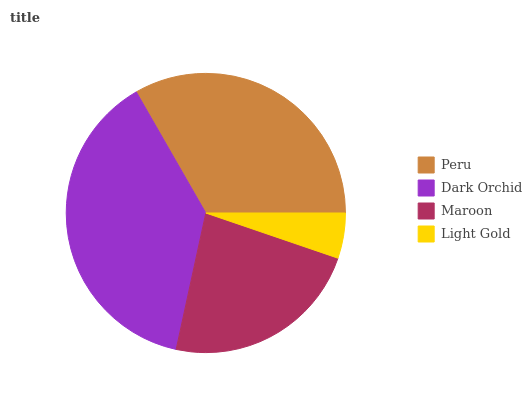Is Light Gold the minimum?
Answer yes or no. Yes. Is Dark Orchid the maximum?
Answer yes or no. Yes. Is Maroon the minimum?
Answer yes or no. No. Is Maroon the maximum?
Answer yes or no. No. Is Dark Orchid greater than Maroon?
Answer yes or no. Yes. Is Maroon less than Dark Orchid?
Answer yes or no. Yes. Is Maroon greater than Dark Orchid?
Answer yes or no. No. Is Dark Orchid less than Maroon?
Answer yes or no. No. Is Peru the high median?
Answer yes or no. Yes. Is Maroon the low median?
Answer yes or no. Yes. Is Dark Orchid the high median?
Answer yes or no. No. Is Peru the low median?
Answer yes or no. No. 